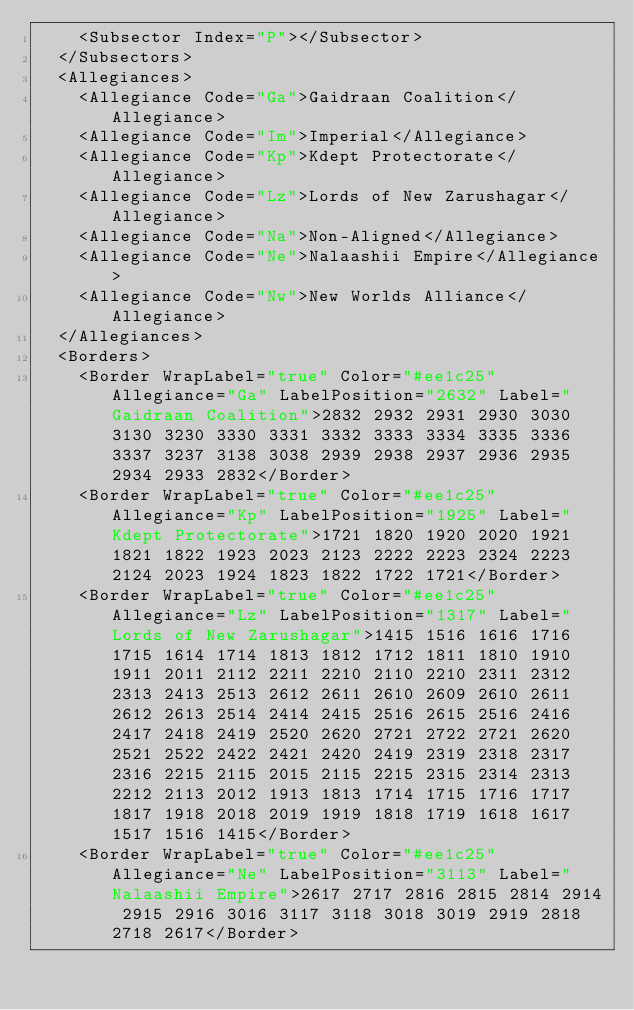<code> <loc_0><loc_0><loc_500><loc_500><_XML_>    <Subsector Index="P"></Subsector>
  </Subsectors>
  <Allegiances>
    <Allegiance Code="Ga">Gaidraan Coalition</Allegiance>
    <Allegiance Code="Im">Imperial</Allegiance>
    <Allegiance Code="Kp">Kdept Protectorate</Allegiance>
    <Allegiance Code="Lz">Lords of New Zarushagar</Allegiance>
    <Allegiance Code="Na">Non-Aligned</Allegiance>
    <Allegiance Code="Ne">Nalaashii Empire</Allegiance>
    <Allegiance Code="Nw">New Worlds Alliance</Allegiance>
  </Allegiances>
  <Borders>
    <Border WrapLabel="true" Color="#ee1c25" Allegiance="Ga" LabelPosition="2632" Label="Gaidraan Coalition">2832 2932 2931 2930 3030 3130 3230 3330 3331 3332 3333 3334 3335 3336 3337 3237 3138 3038 2939 2938 2937 2936 2935 2934 2933 2832</Border>
    <Border WrapLabel="true" Color="#ee1c25" Allegiance="Kp" LabelPosition="1925" Label="Kdept Protectorate">1721 1820 1920 2020 1921 1821 1822 1923 2023 2123 2222 2223 2324 2223 2124 2023 1924 1823 1822 1722 1721</Border>
    <Border WrapLabel="true" Color="#ee1c25" Allegiance="Lz" LabelPosition="1317" Label="Lords of New Zarushagar">1415 1516 1616 1716 1715 1614 1714 1813 1812 1712 1811 1810 1910 1911 2011 2112 2211 2210 2110 2210 2311 2312 2313 2413 2513 2612 2611 2610 2609 2610 2611 2612 2613 2514 2414 2415 2516 2615 2516 2416 2417 2418 2419 2520 2620 2721 2722 2721 2620 2521 2522 2422 2421 2420 2419 2319 2318 2317 2316 2215 2115 2015 2115 2215 2315 2314 2313 2212 2113 2012 1913 1813 1714 1715 1716 1717 1817 1918 2018 2019 1919 1818 1719 1618 1617 1517 1516 1415</Border>
    <Border WrapLabel="true" Color="#ee1c25" Allegiance="Ne" LabelPosition="3113" Label="Nalaashii Empire">2617 2717 2816 2815 2814 2914 2915 2916 3016 3117 3118 3018 3019 2919 2818 2718 2617</Border></code> 